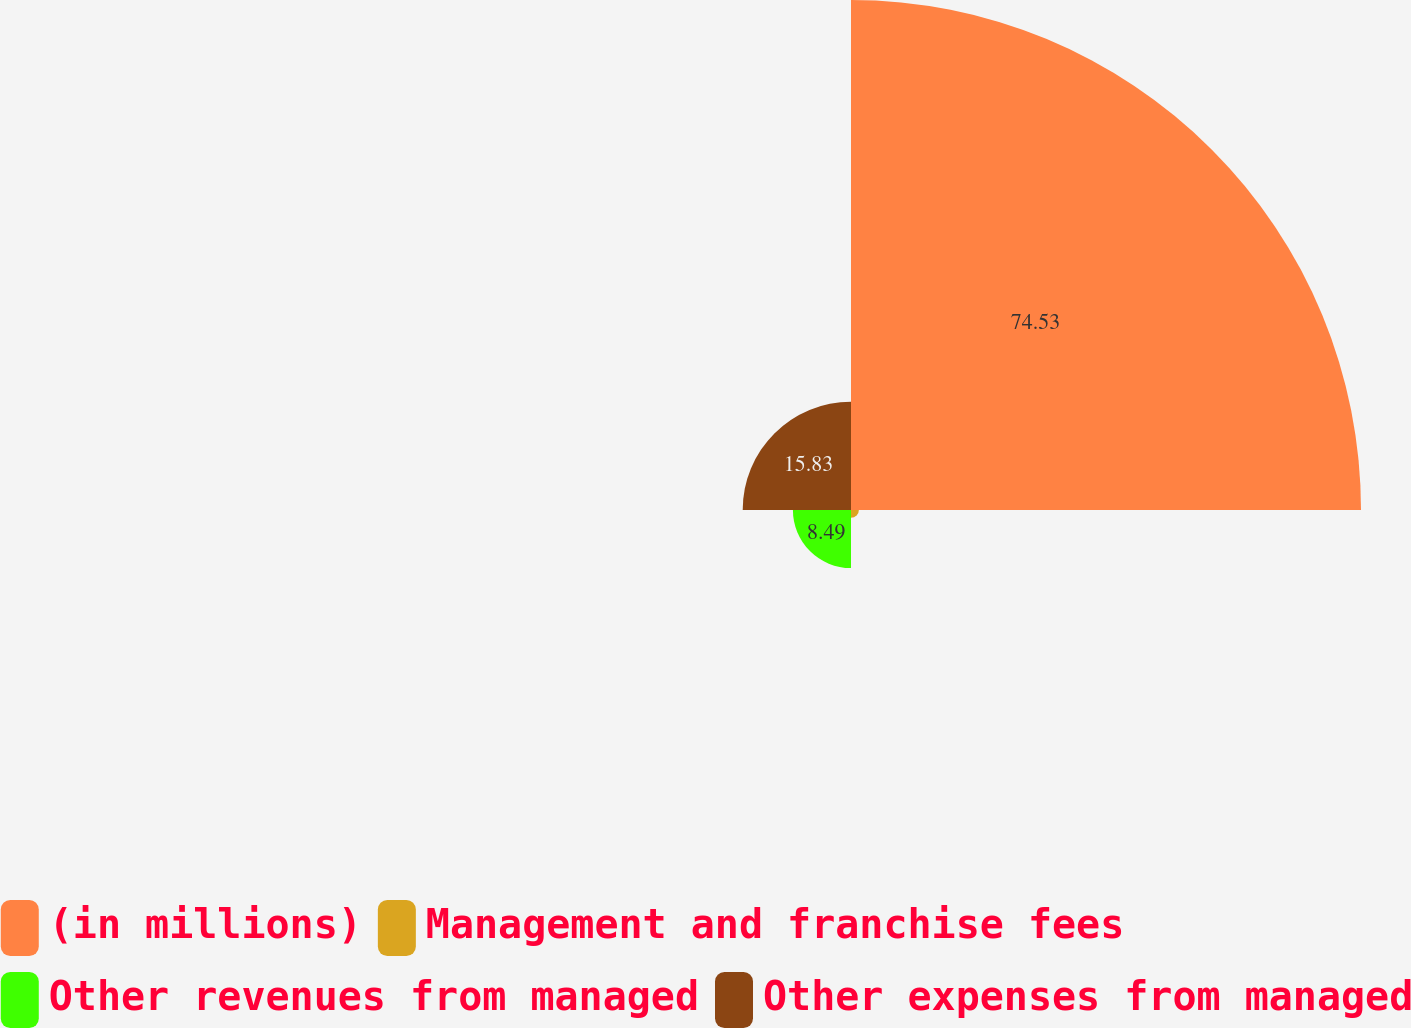Convert chart to OTSL. <chart><loc_0><loc_0><loc_500><loc_500><pie_chart><fcel>(in millions)<fcel>Management and franchise fees<fcel>Other revenues from managed<fcel>Other expenses from managed<nl><fcel>74.54%<fcel>1.15%<fcel>8.49%<fcel>15.83%<nl></chart> 